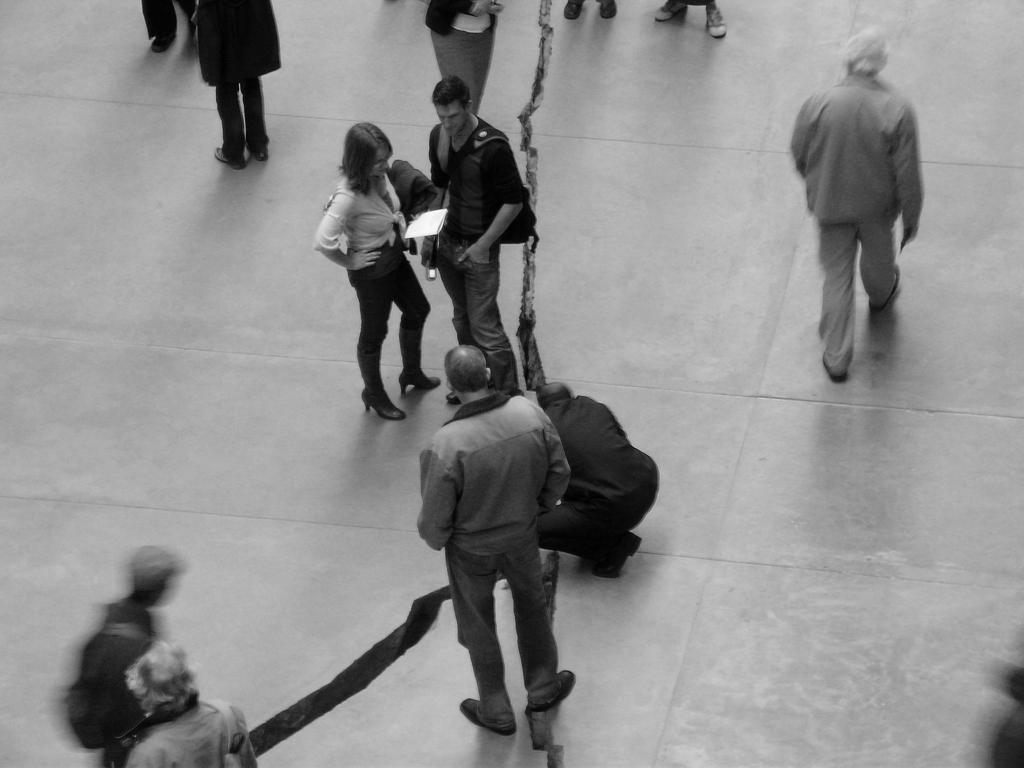What are the persons in the image doing? There are persons standing and walking in the image. Where are the persons located in the image? The persons are on the floor. What type of soap can be seen in the image? There is no soap present in the image. What kind of pancake is being prepared by the persons in the image? There is no pancake or preparation of pancakes visible in the image. 